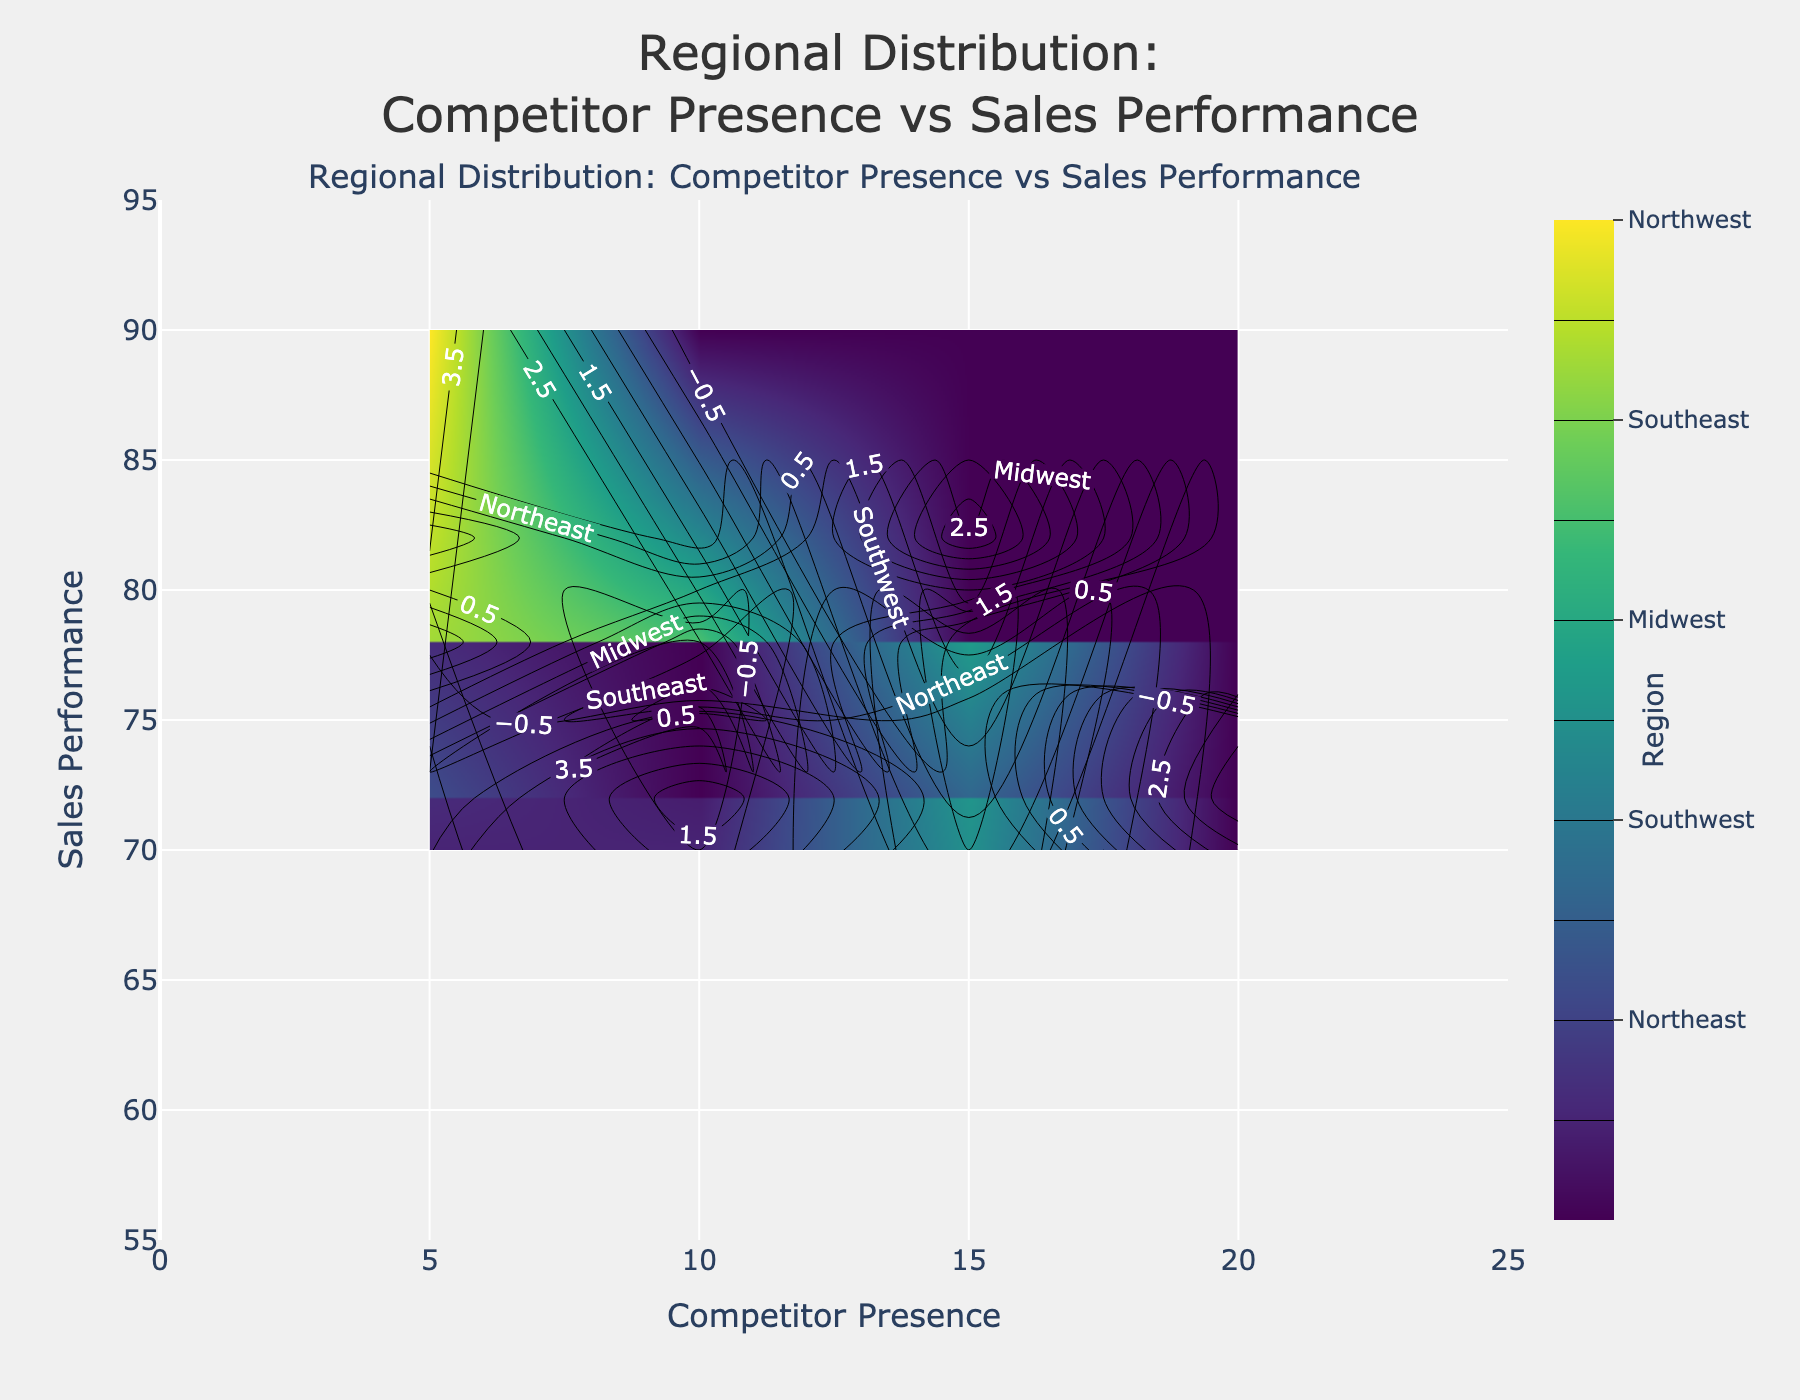What's the title of the figure? The title is usually located at the top and it summarizes the main theme of the plot. In this case, it reads "Regional Distribution: Competitor Presence vs Sales Performance."
Answer: Regional Distribution: Competitor Presence vs Sales Performance What's the range of the x-axis? To find the range of the x-axis, check the minimum and maximum values along the horizontal axis. Here, it ranges from 0 to 25.
Answer: 0 to 25 Which region sees the highest sales performance when competitor presence is 10? Look for the contour value corresponding to those settings on the figure. From the color scale and the plot, the highest sales performance for a competitor presence of 10 occurs in the Southeast region.
Answer: Southeast How does sales performance trend with increasing competitor presence in the Northwest region? Trace the contour lines specific to the Northwest region in the plot as competitor presence increases from 5 to 20. It shows that sales performance decreases gradually.
Answer: Sales performance decreases Which region maintains the highest overall sales performance in the plot? By checking the highest contour value across all regions in the figure, the Northwest region stands out with sales performance peaking at 90.
Answer: Northwest What is the approximate sales performance in the Midwest when the competitor presence is 15? Find the contour line corresponding to the Midwest region at a competitor presence of 15. The contour line indicates a sales performance of approximately 68.
Answer: 68 Is there any region where sales performance is unaffected by competitor presence? Review the contour plots and see if any region's sales performance remains constant across different competitor presence levels. No region exhibits a completely flat trend; all have some degree of change.
Answer: No What’s the common trend in the figure when competitor presence increases from 5 to 20? Considering all regions, observe how sales performance contours change from left to right. There's a general trend of decreasing sales performance with increasing competitor presence.
Answer: Sales performance decreases Between which regions do we see the largest difference in sales performance at the same level of competitor presence? Compare all regions' sales performances at multiple levels of competitor presence. The largest divergence can be observed between the Southeast and Northeast regions at a competitor presence level of 5.
Answer: Southeast and Northeast If you were to interpret an increase in competitor presence from 5 to 15, which region would face the most significant drop in sales performance? Look for the steepest gradient change in the contour plot between these points. The Northeast region shows the most significant drop in sales performance when increasing competitor presence from 5 to 15.
Answer: Northeast 